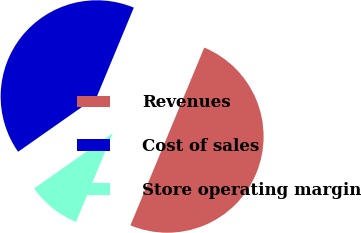Convert chart. <chart><loc_0><loc_0><loc_500><loc_500><pie_chart><fcel>Revenues<fcel>Cost of sales<fcel>Store operating margin<nl><fcel>50.0%<fcel>41.0%<fcel>9.0%<nl></chart> 